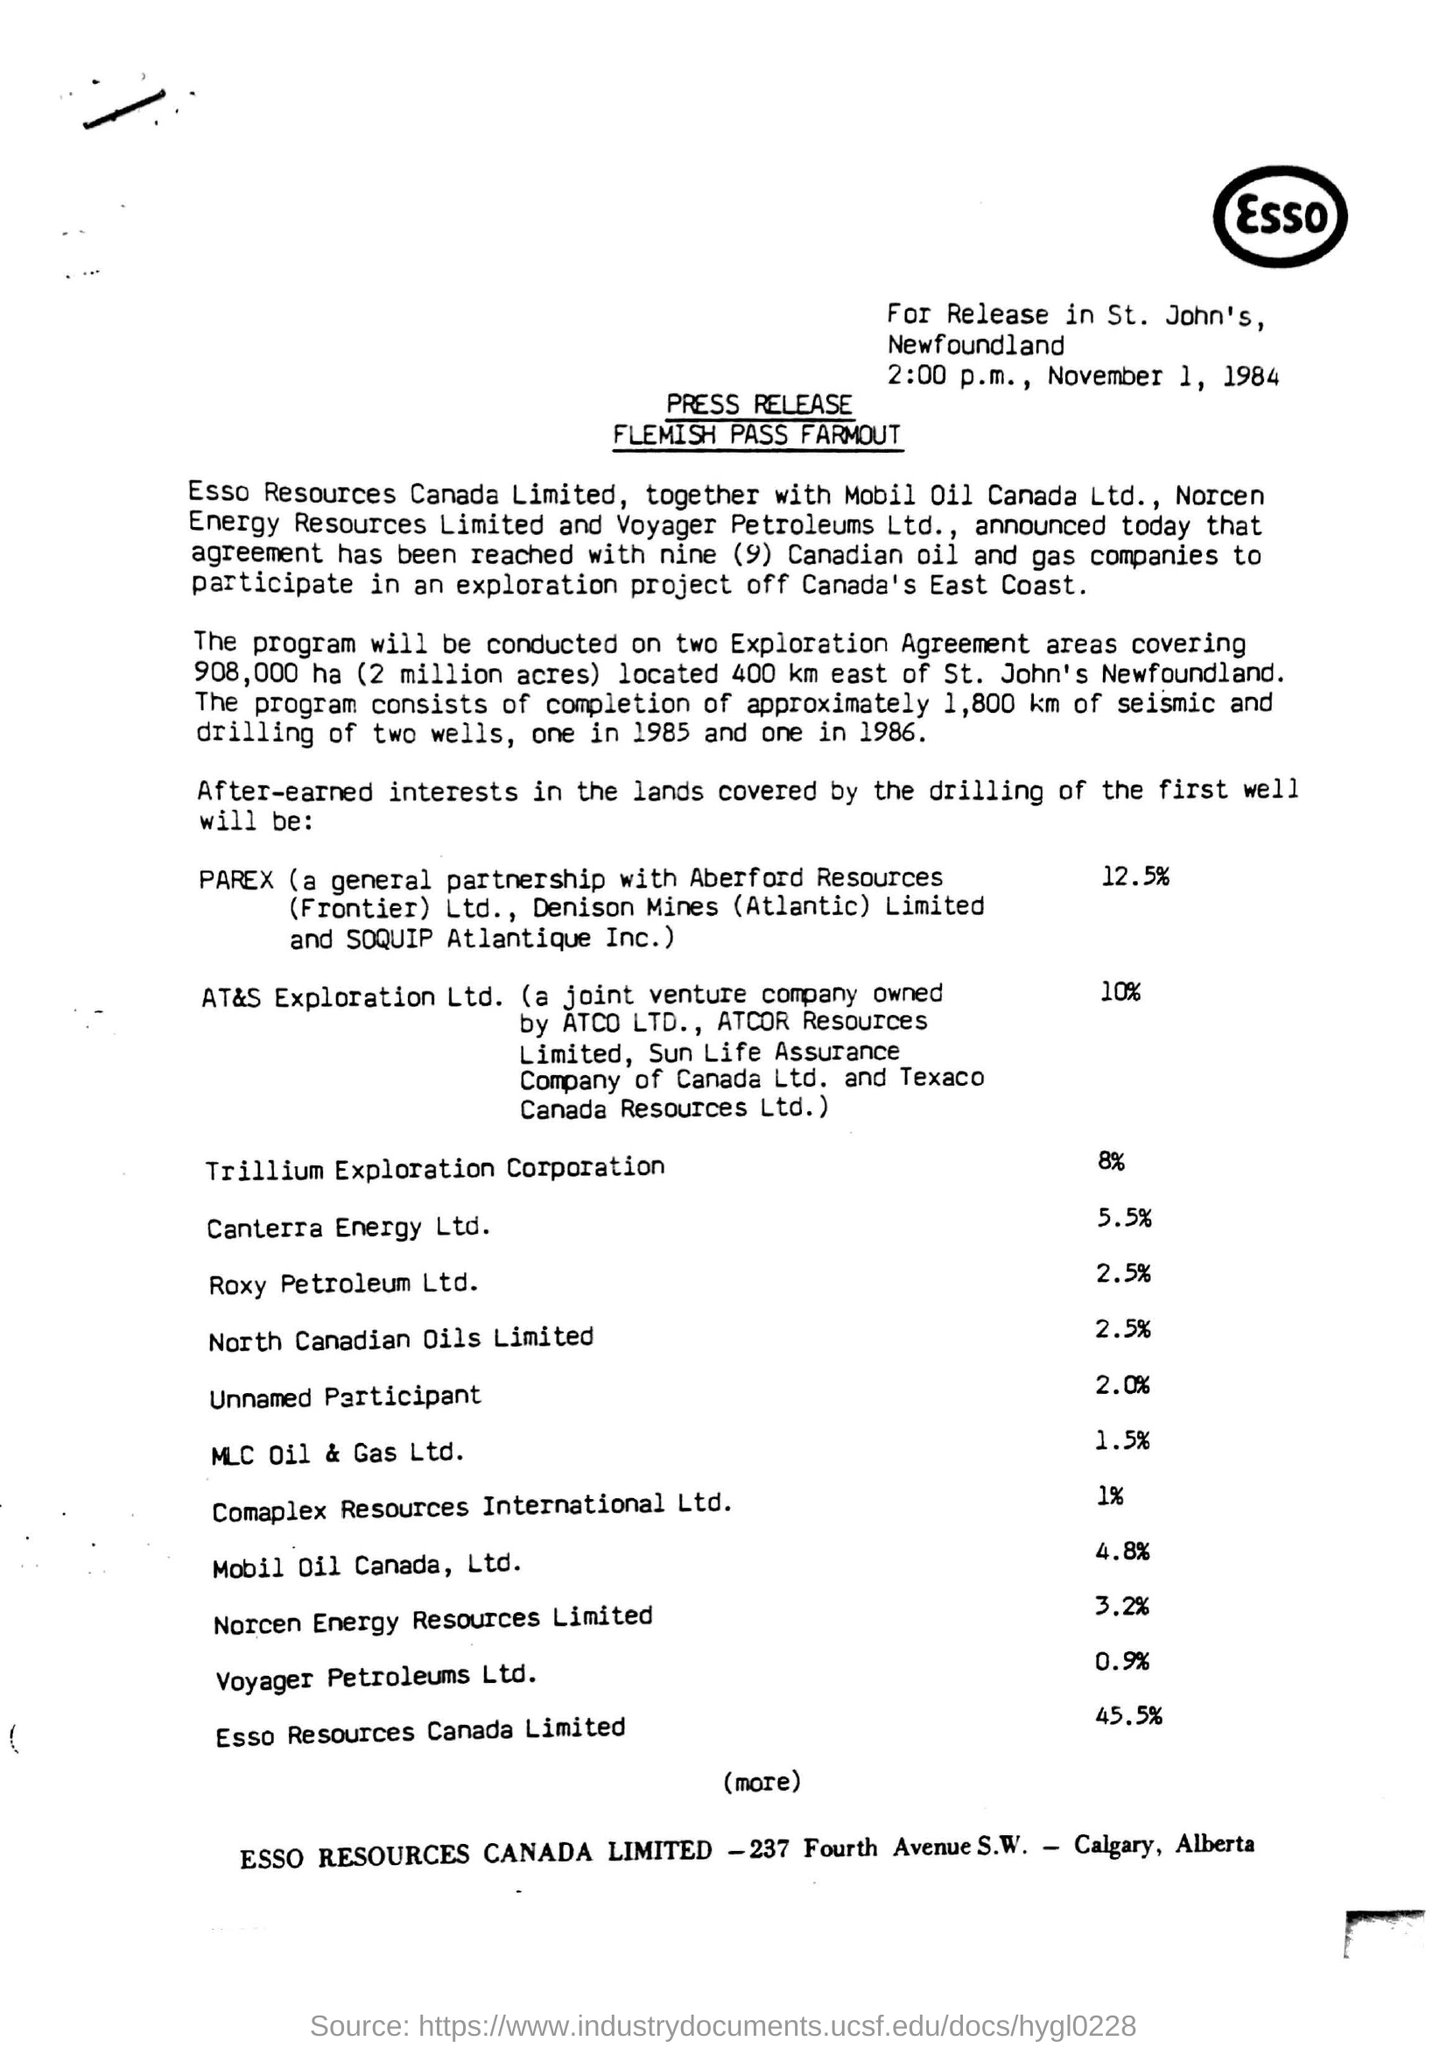Draw attention to some important aspects in this diagram. The top right corner of the document contains the written ESSO. Canterra Energy Ltd has a percentage of 5.5%. Mobil Oil Canada, Ltd. currently holds a 4.8% ownership stake in the company. The date mentioned at the top of the document is November 1, 1984. The highest percentage in the given list is 45.5%. 